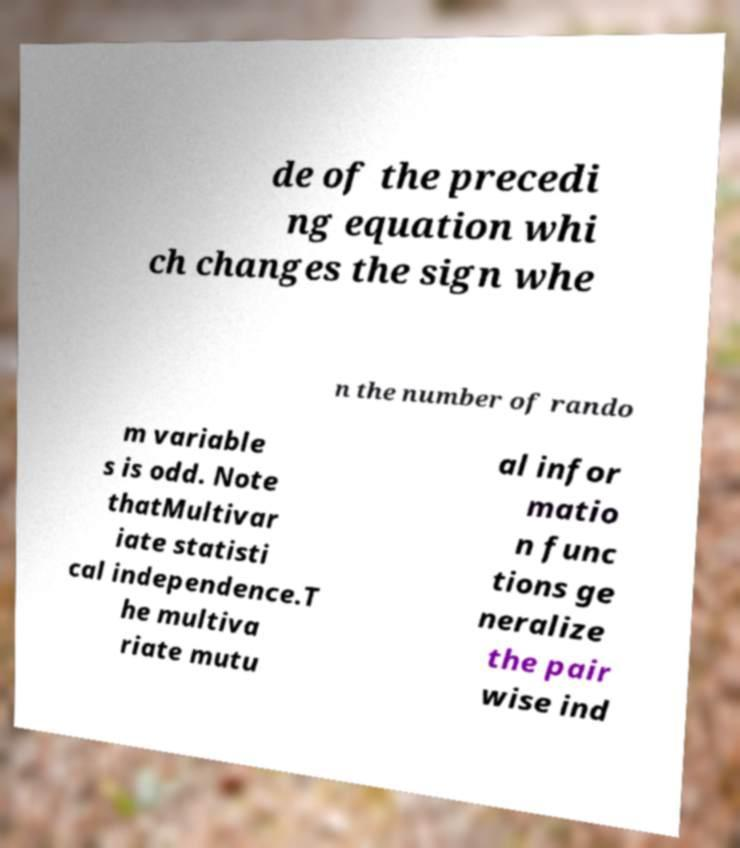Can you accurately transcribe the text from the provided image for me? de of the precedi ng equation whi ch changes the sign whe n the number of rando m variable s is odd. Note thatMultivar iate statisti cal independence.T he multiva riate mutu al infor matio n func tions ge neralize the pair wise ind 